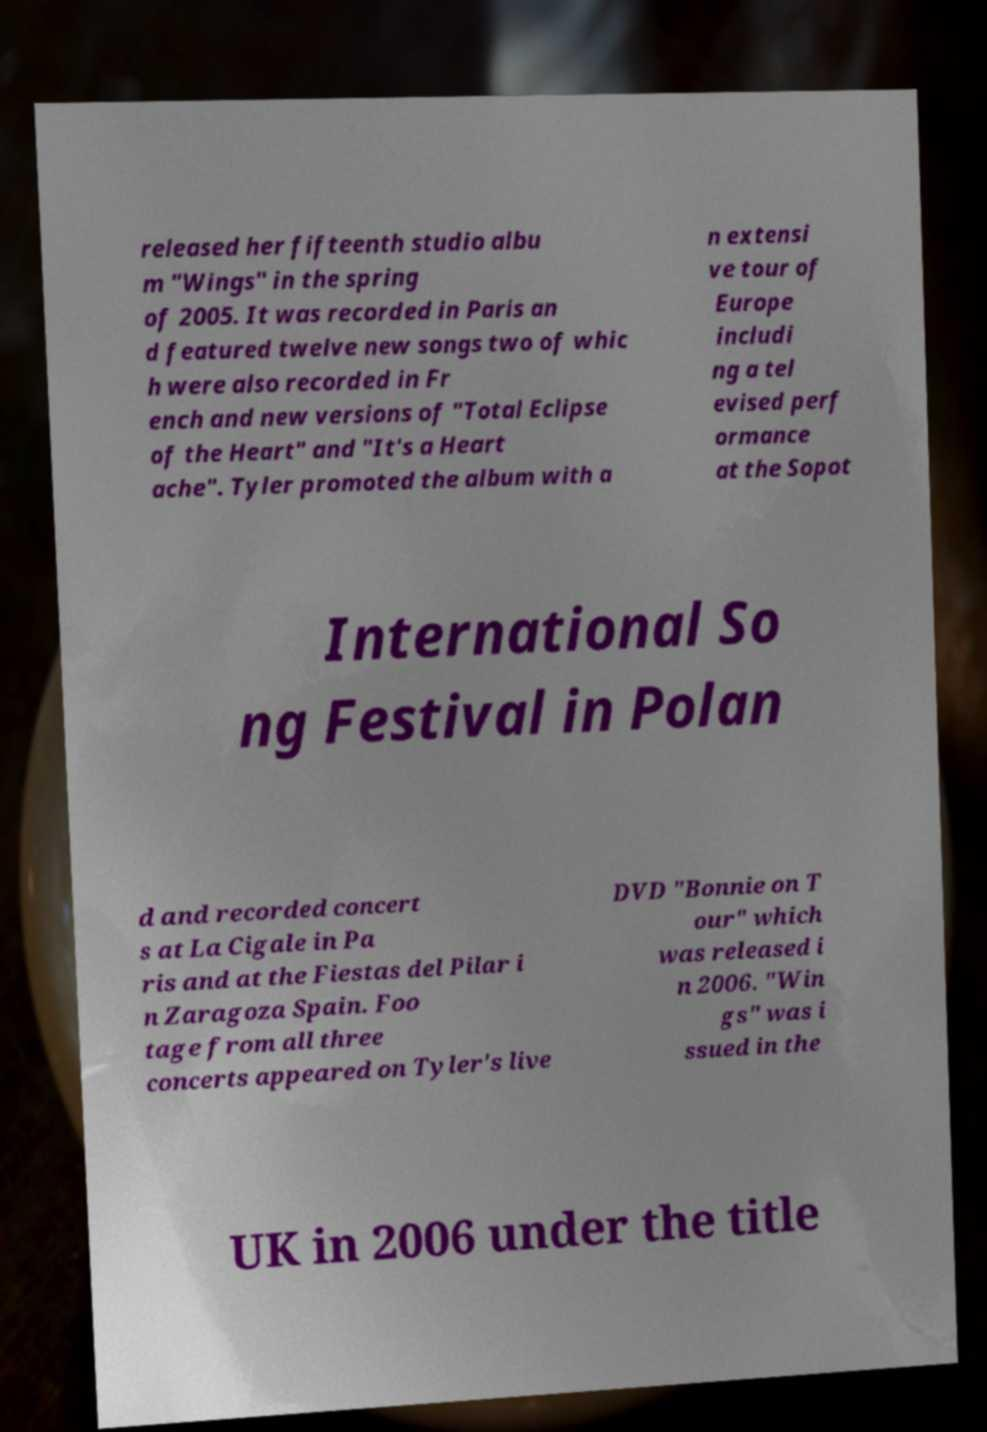There's text embedded in this image that I need extracted. Can you transcribe it verbatim? released her fifteenth studio albu m "Wings" in the spring of 2005. It was recorded in Paris an d featured twelve new songs two of whic h were also recorded in Fr ench and new versions of "Total Eclipse of the Heart" and "It's a Heart ache". Tyler promoted the album with a n extensi ve tour of Europe includi ng a tel evised perf ormance at the Sopot International So ng Festival in Polan d and recorded concert s at La Cigale in Pa ris and at the Fiestas del Pilar i n Zaragoza Spain. Foo tage from all three concerts appeared on Tyler's live DVD "Bonnie on T our" which was released i n 2006. "Win gs" was i ssued in the UK in 2006 under the title 